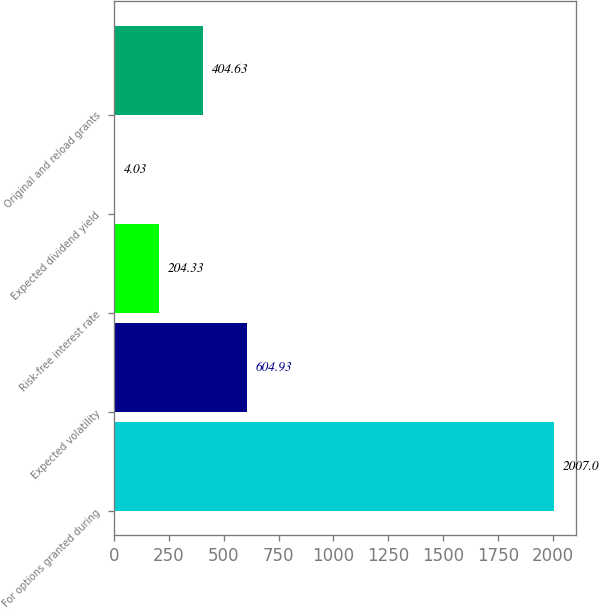Convert chart to OTSL. <chart><loc_0><loc_0><loc_500><loc_500><bar_chart><fcel>For options granted during<fcel>Expected volatility<fcel>Risk-free interest rate<fcel>Expected dividend yield<fcel>Original and reload grants<nl><fcel>2007<fcel>604.93<fcel>204.33<fcel>4.03<fcel>404.63<nl></chart> 